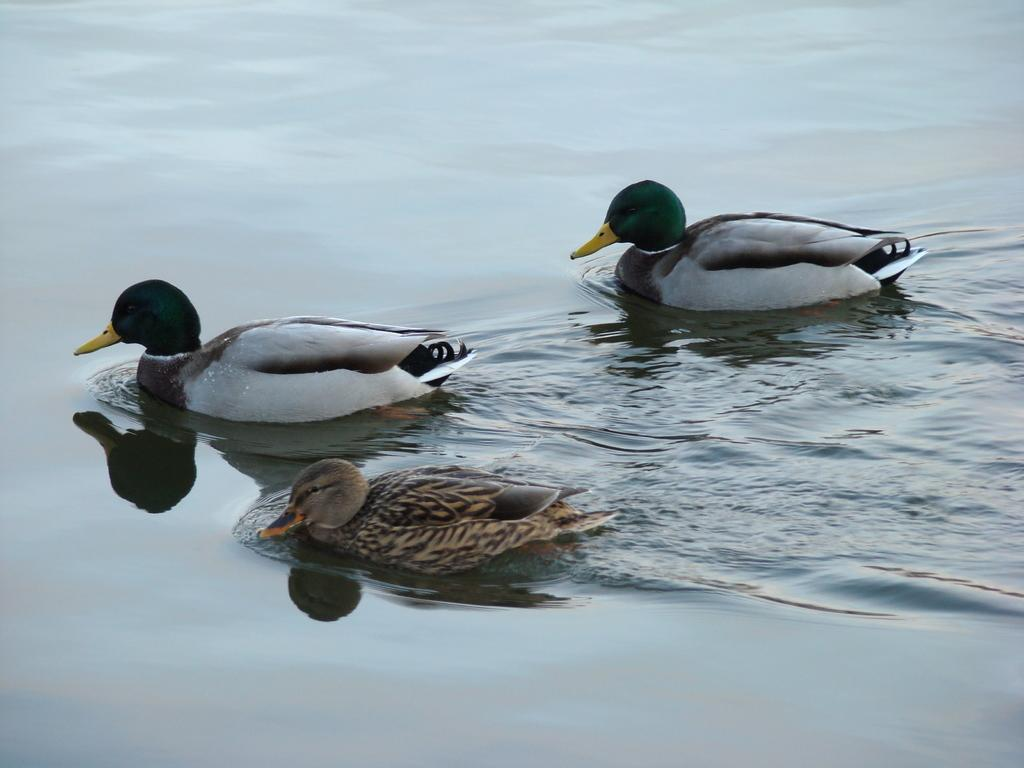What animals can be seen in the image? There are ducks in the image. What are the ducks doing in the image? The ducks are swimming in the water. What type of popcorn is being used to fuel the ducks' growth in the image? There is no popcorn or indication of growth in the image; it simply features ducks swimming in the water. 